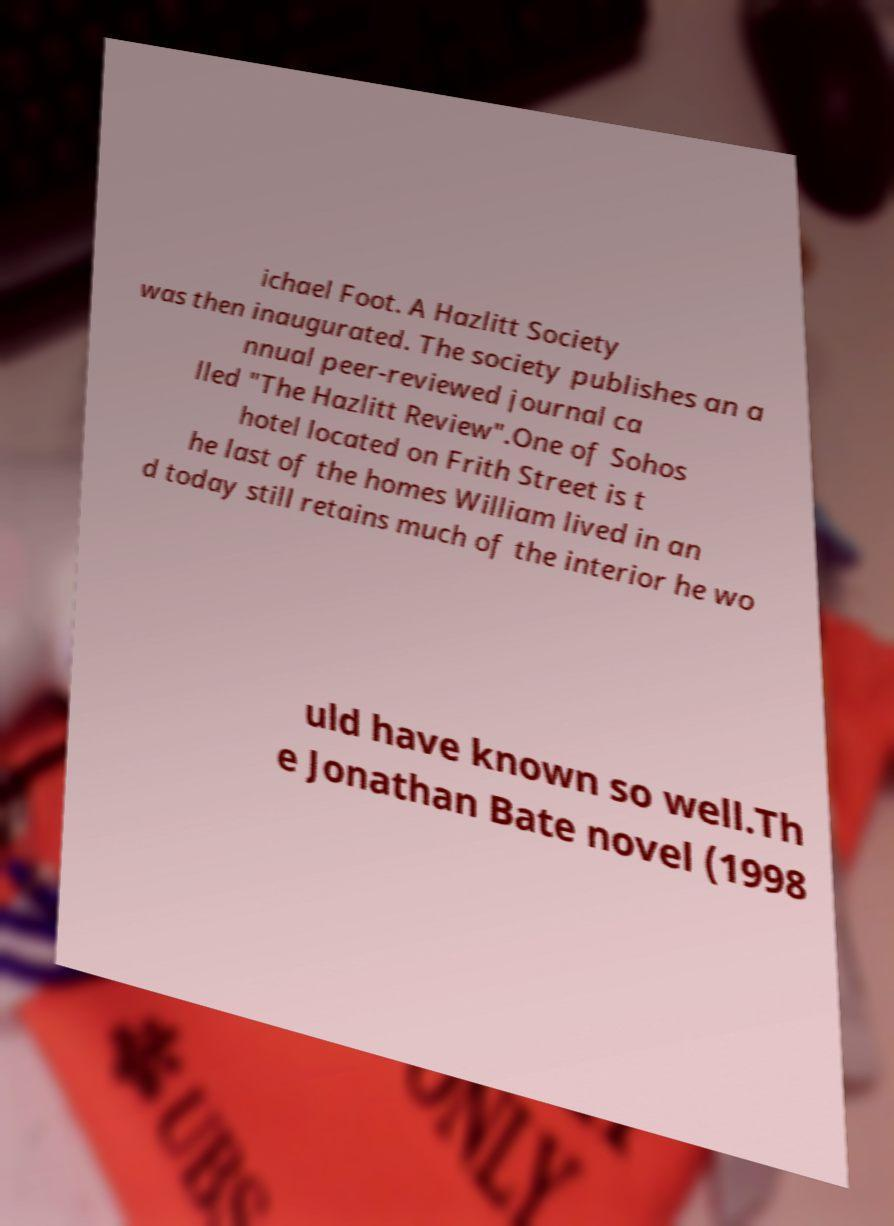Can you accurately transcribe the text from the provided image for me? ichael Foot. A Hazlitt Society was then inaugurated. The society publishes an a nnual peer-reviewed journal ca lled "The Hazlitt Review".One of Sohos hotel located on Frith Street is t he last of the homes William lived in an d today still retains much of the interior he wo uld have known so well.Th e Jonathan Bate novel (1998 